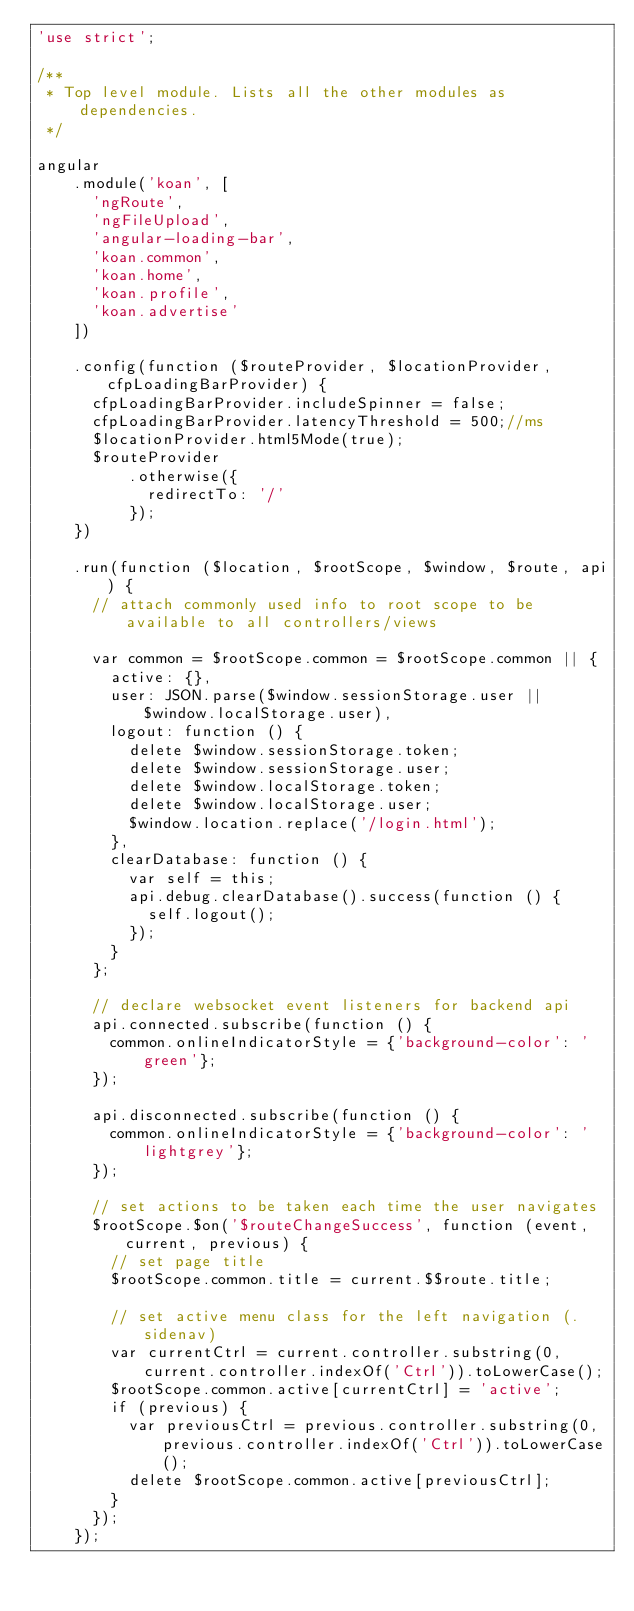Convert code to text. <code><loc_0><loc_0><loc_500><loc_500><_JavaScript_>'use strict';

/**
 * Top level module. Lists all the other modules as dependencies.
 */

angular
    .module('koan', [
      'ngRoute',
      'ngFileUpload',
      'angular-loading-bar',
      'koan.common',
      'koan.home',
      'koan.profile',
      'koan.advertise'
    ])

    .config(function ($routeProvider, $locationProvider, cfpLoadingBarProvider) {
      cfpLoadingBarProvider.includeSpinner = false;
      cfpLoadingBarProvider.latencyThreshold = 500;//ms
      $locationProvider.html5Mode(true);
      $routeProvider
          .otherwise({
            redirectTo: '/'
          });
    })

    .run(function ($location, $rootScope, $window, $route, api) {
      // attach commonly used info to root scope to be available to all controllers/views
      
      var common = $rootScope.common = $rootScope.common || {
        active: {},
        user: JSON.parse($window.sessionStorage.user || $window.localStorage.user),
        logout: function () {
          delete $window.sessionStorage.token;
          delete $window.sessionStorage.user;
          delete $window.localStorage.token;
          delete $window.localStorage.user;
          $window.location.replace('/login.html');
        },
        clearDatabase: function () {
          var self = this;
          api.debug.clearDatabase().success(function () {
            self.logout();
          });
        }
      };

      // declare websocket event listeners for backend api
      api.connected.subscribe(function () {
        common.onlineIndicatorStyle = {'background-color': 'green'};
      });

      api.disconnected.subscribe(function () {
        common.onlineIndicatorStyle = {'background-color': 'lightgrey'};
      });

      // set actions to be taken each time the user navigates
      $rootScope.$on('$routeChangeSuccess', function (event, current, previous) {
        // set page title
        $rootScope.common.title = current.$$route.title;

        // set active menu class for the left navigation (.sidenav)
        var currentCtrl = current.controller.substring(0, current.controller.indexOf('Ctrl')).toLowerCase();
        $rootScope.common.active[currentCtrl] = 'active';
        if (previous) {
          var previousCtrl = previous.controller.substring(0, previous.controller.indexOf('Ctrl')).toLowerCase();
          delete $rootScope.common.active[previousCtrl];
        }
      });
    });</code> 